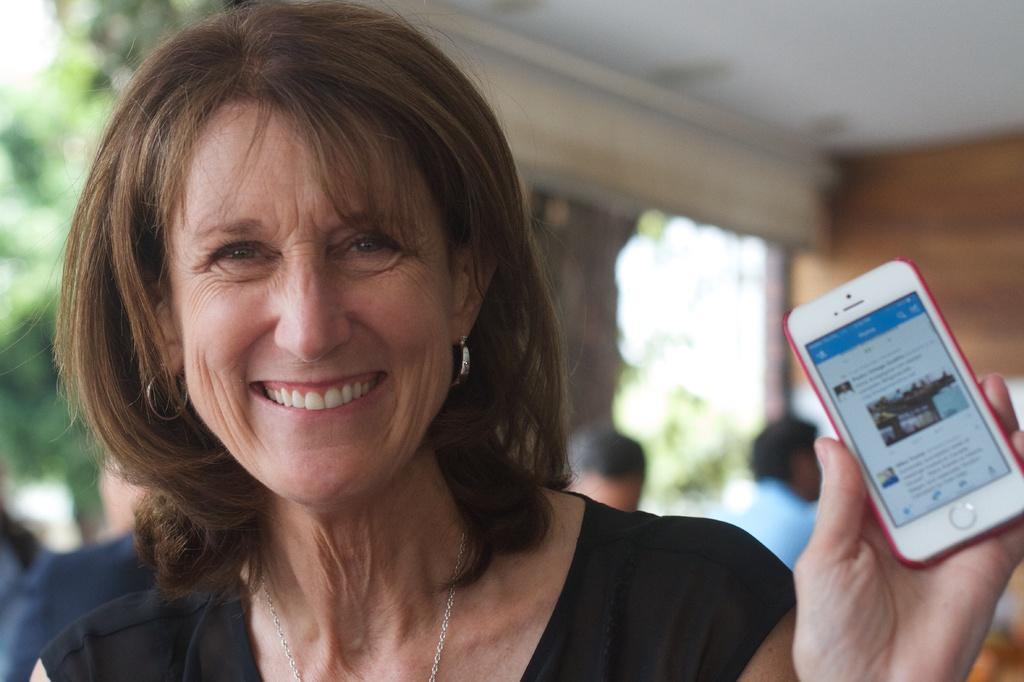How would you summarize this image in a sentence or two? In the image we can see one woman is standing and she is smiling and she is holding mobile phone. In the background there is a wall,trees and few persons were sitting on the chair. 